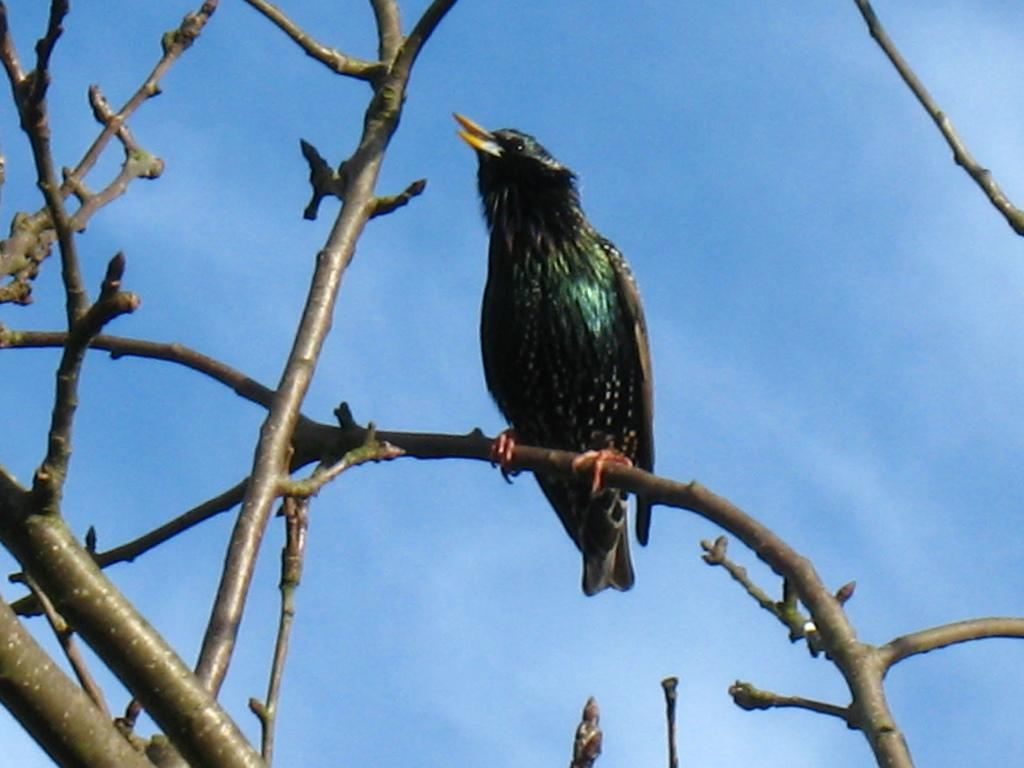What type of animal can be seen in the image? There is a bird in the image. Where is the bird located? The bird is on a tree stem. How many tree stems are visible in the image? There are multiple tree stems visible in the image. What can be seen in the distance in the image? The sky is visible in the background of the image. What type of doll does the bird's aunt have approval for in the image? There is no doll or mention of an aunt in the image, so it is not possible to answer that question. 